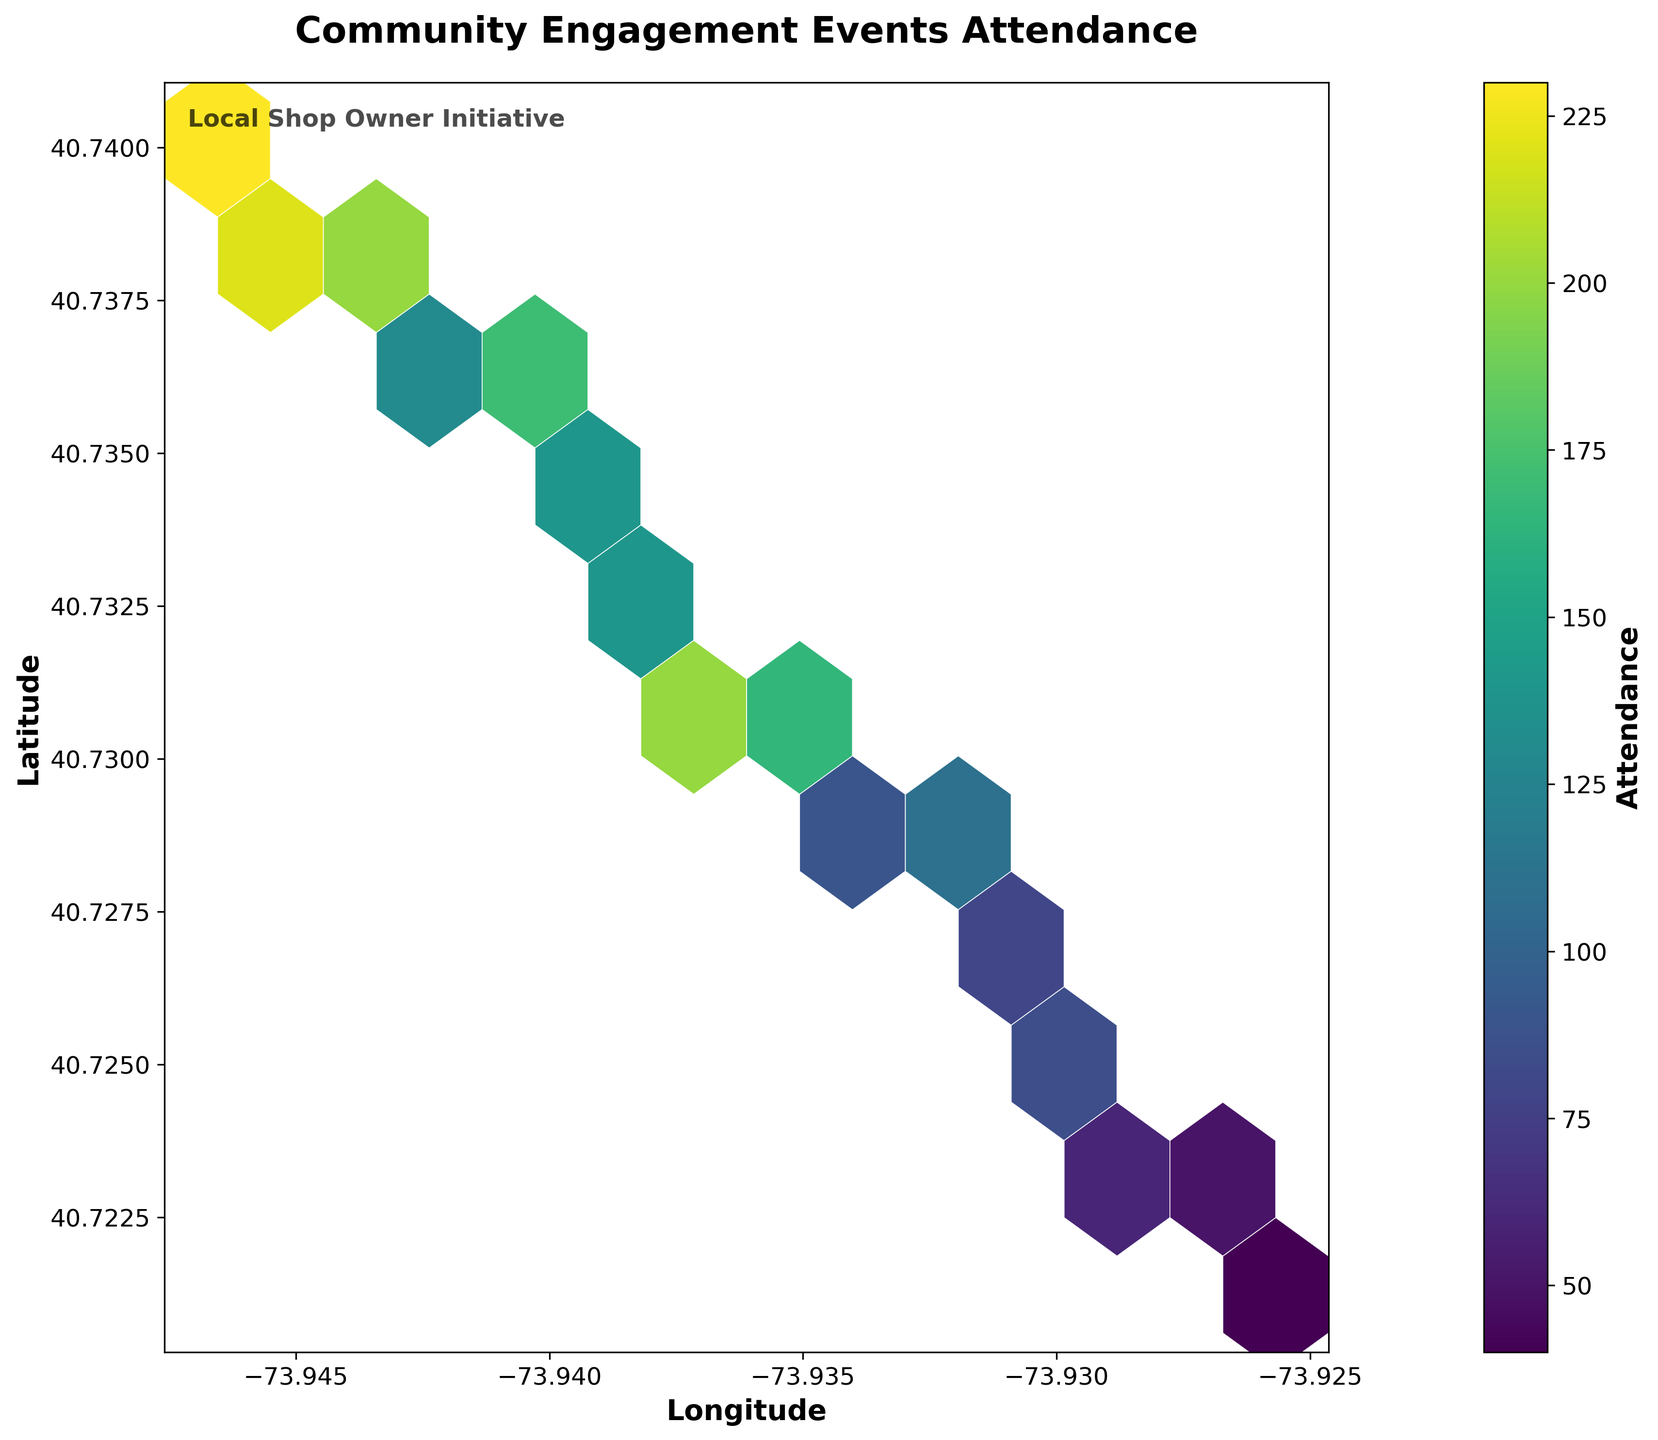What's the title of the figure? The title of the figure is at the top and it reads "Community Engagement Events Attendance".
Answer: Community Engagement Events Attendance What does the color gradient represent in the plot? The color gradient in a Hexbin Plot usually indicates the density or magnitude of the data points within the hexagon bins. Here, it shows the attendance levels with lighter colors representing lower attendance and darker colors for higher attendance.
Answer: Attendance levels Which area shows the highest attendance for community engagement events? The hexbin with the darkest color within the plot indicates the highest attendance area. By observing the plot, we see the highest attendance near the coordinates (-73.936, 40.731).
Answer: Near (-73.936, 40.731) Is the attendance more concentrated in any specific part of the region? Attendance appears more concentrated in the central region of the plot where the color becomes consistently darker, indicating higher attendance densities.
Answer: Yes, in the central region How does the attendance vary as you move from west to east within the region? As you move from the left (west) to the right (east) in the plot, the density of color changes. Initially, the colors are lighter (lower attendance) and become darker towards the central part, eventually getting lighter again towards the east.
Answer: It peaks in the center and drops off towards the east What's the average level of attendance for the location with the highest number of events? To find the average attendance for the location with the highest number of events, locate the densest hexbin and note its approximate value. Assume this location had multiple events; sum these values and divide by the number of entries. If the densest hexbin indicates an attendance of 200 on average and this was consistent across events, it will be 200.
Answer: 200 Compare the attendance near the coordinates (-73.930, 40.725) and (-73.940, 40.735). Where is it higher? By visually comparing the color intensity of the hexagons near these coordinates, we deduce that (-73.940, 40.735) has a darker colored hexbin, indicating higher attendance than (-73.930, 40.725).
Answer: Near (-73.940, 40.735) What is the meaning of the text "Local Shop Owner Initiative" within the figure? This text indicates a note or annotation within the plot, typically added for context or attribution. It informs the viewer that the figure is related to an initiative by the local shop owner.
Answer: Annotation for context 